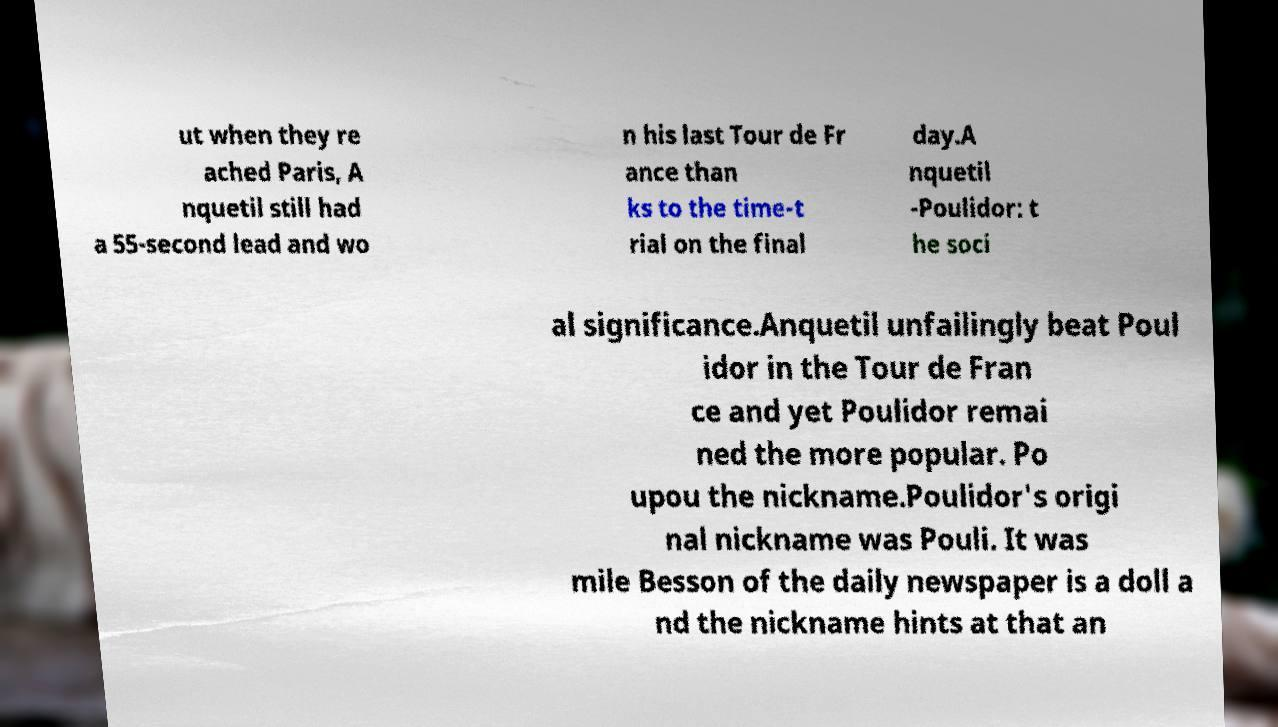There's text embedded in this image that I need extracted. Can you transcribe it verbatim? ut when they re ached Paris, A nquetil still had a 55-second lead and wo n his last Tour de Fr ance than ks to the time-t rial on the final day.A nquetil -Poulidor: t he soci al significance.Anquetil unfailingly beat Poul idor in the Tour de Fran ce and yet Poulidor remai ned the more popular. Po upou the nickname.Poulidor's origi nal nickname was Pouli. It was mile Besson of the daily newspaper is a doll a nd the nickname hints at that an 